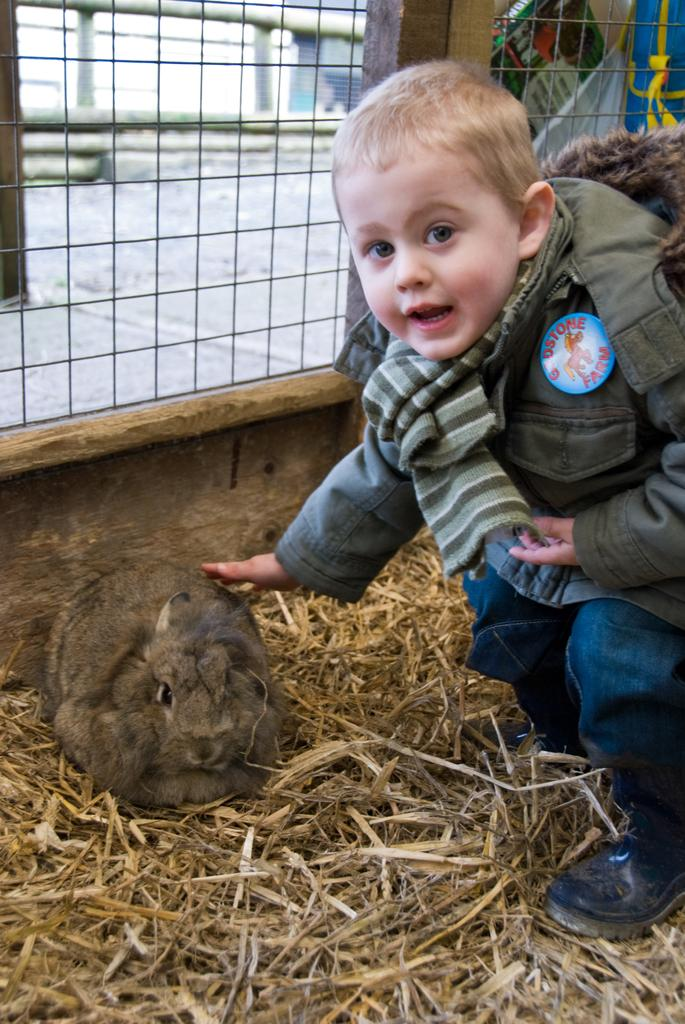What animal is present in the image? There is a rabbit in the image. Where is the rabbit located? The rabbit is on the grass. Who else is in the image? There is a boy in the image. What is the boy doing with the rabbit? The boy is touching the rabbit. What can be seen in the background of the image? There is fencing in the background of the image. What type of bell can be heard ringing in the image? There is no bell present in the image, and therefore no sound can be heard. 